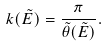Convert formula to latex. <formula><loc_0><loc_0><loc_500><loc_500>k ( \tilde { E } ) = \frac { \pi } { \tilde { \theta } ( \tilde { E } ) } .</formula> 